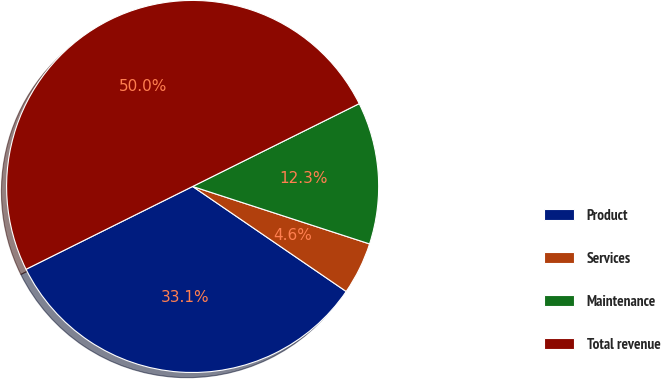Convert chart to OTSL. <chart><loc_0><loc_0><loc_500><loc_500><pie_chart><fcel>Product<fcel>Services<fcel>Maintenance<fcel>Total revenue<nl><fcel>33.11%<fcel>4.55%<fcel>12.34%<fcel>50.0%<nl></chart> 